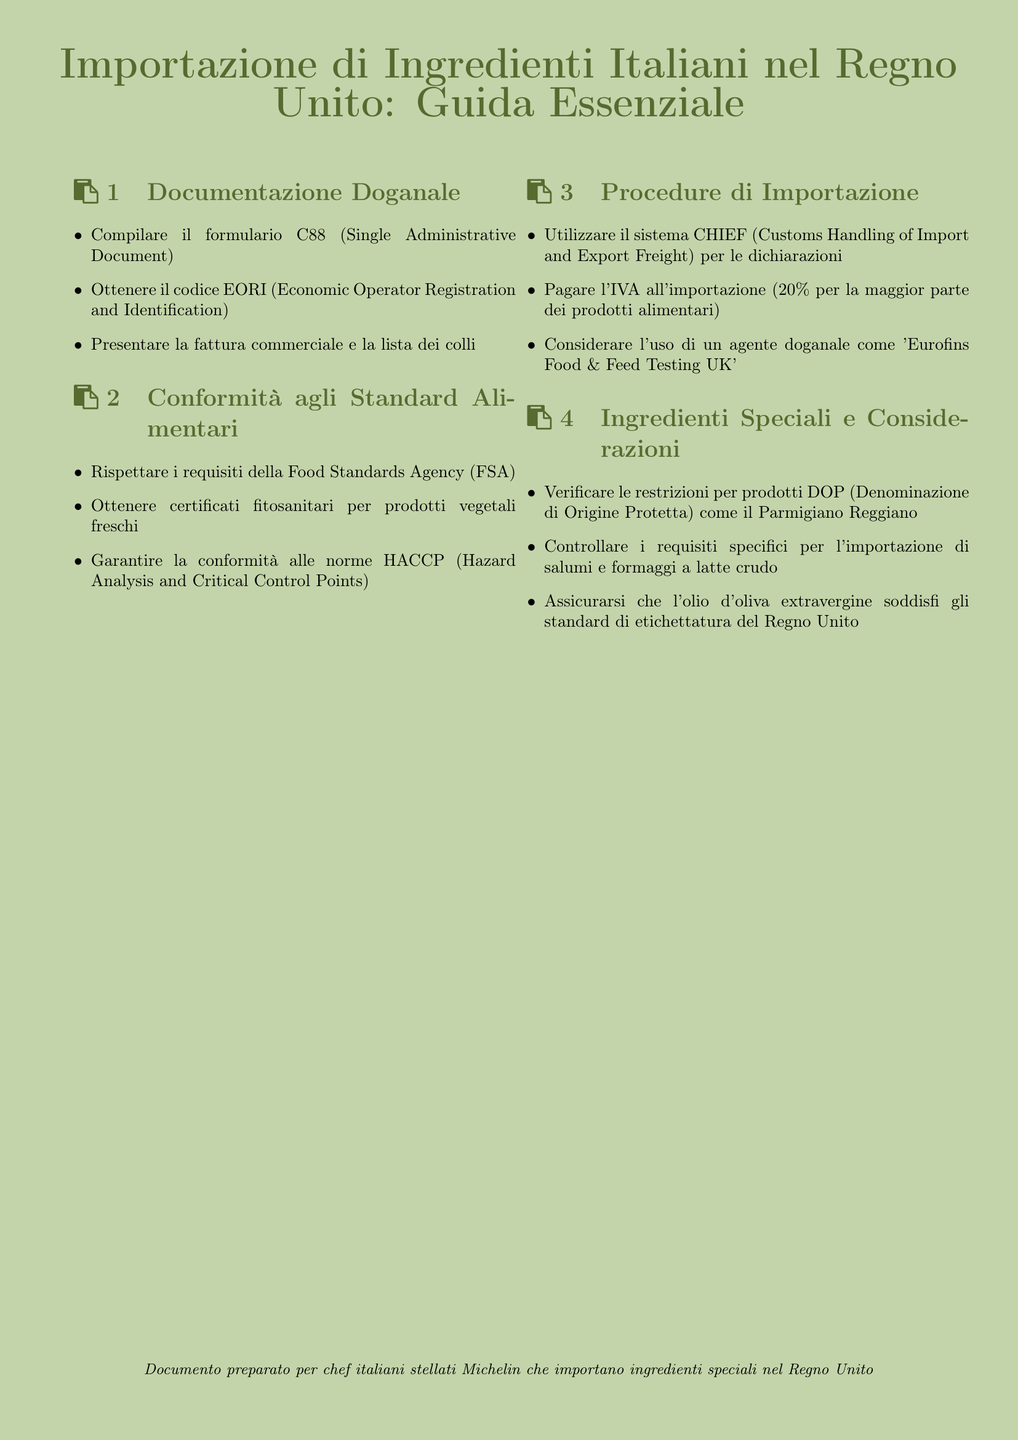what document is used for customs declaration? The document used for customs declaration is the C88 (Single Administrative Document).
Answer: C88 what approval is required for fresh plant products? Fresh plant products require a phytosanitary certificate for import.
Answer: certificati fitosanitari what percentage is the import VAT for most food products? The import VAT for most food products is 20%.
Answer: 20% which agency's requirements must be respected? The requirements of the Food Standards Agency (FSA) must be respected.
Answer: Food Standards Agency (FSA) what must be verified for DOP products? Restrictions for DOP (Denominazione di Origine Protetta) products must be verified.
Answer: restrizioni per prodotti DOP which system should be used for import declarations? The CHIEF (Customs Handling of Import and Export Freight) system should be used for import declarations.
Answer: CHIEF what type of agent may be considered for customs? An agent such as 'Eurofins Food & Feed Testing UK' may be considered for customs.
Answer: 'Eurofins Food & Feed Testing UK' what is a requirement for extra virgin olive oil? Extra virgin olive oil must meet UK labeling standards.
Answer: etichettatura del Regno Unito 